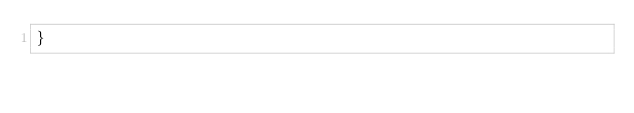Convert code to text. <code><loc_0><loc_0><loc_500><loc_500><_CSS_>}
</code> 